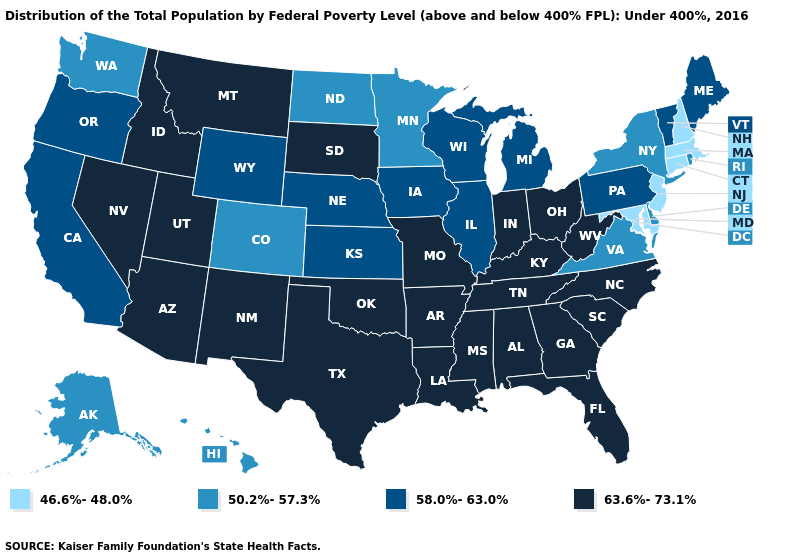Name the states that have a value in the range 50.2%-57.3%?
Short answer required. Alaska, Colorado, Delaware, Hawaii, Minnesota, New York, North Dakota, Rhode Island, Virginia, Washington. How many symbols are there in the legend?
Write a very short answer. 4. Which states have the highest value in the USA?
Write a very short answer. Alabama, Arizona, Arkansas, Florida, Georgia, Idaho, Indiana, Kentucky, Louisiana, Mississippi, Missouri, Montana, Nevada, New Mexico, North Carolina, Ohio, Oklahoma, South Carolina, South Dakota, Tennessee, Texas, Utah, West Virginia. What is the value of Oklahoma?
Give a very brief answer. 63.6%-73.1%. Name the states that have a value in the range 58.0%-63.0%?
Answer briefly. California, Illinois, Iowa, Kansas, Maine, Michigan, Nebraska, Oregon, Pennsylvania, Vermont, Wisconsin, Wyoming. What is the highest value in the USA?
Be succinct. 63.6%-73.1%. Does Arkansas have a higher value than New Mexico?
Be succinct. No. Among the states that border Massachusetts , does New Hampshire have the lowest value?
Be succinct. Yes. What is the value of Pennsylvania?
Short answer required. 58.0%-63.0%. What is the value of North Dakota?
Be succinct. 50.2%-57.3%. What is the value of Arizona?
Short answer required. 63.6%-73.1%. What is the value of North Dakota?
Concise answer only. 50.2%-57.3%. What is the lowest value in the West?
Answer briefly. 50.2%-57.3%. Name the states that have a value in the range 46.6%-48.0%?
Give a very brief answer. Connecticut, Maryland, Massachusetts, New Hampshire, New Jersey. 